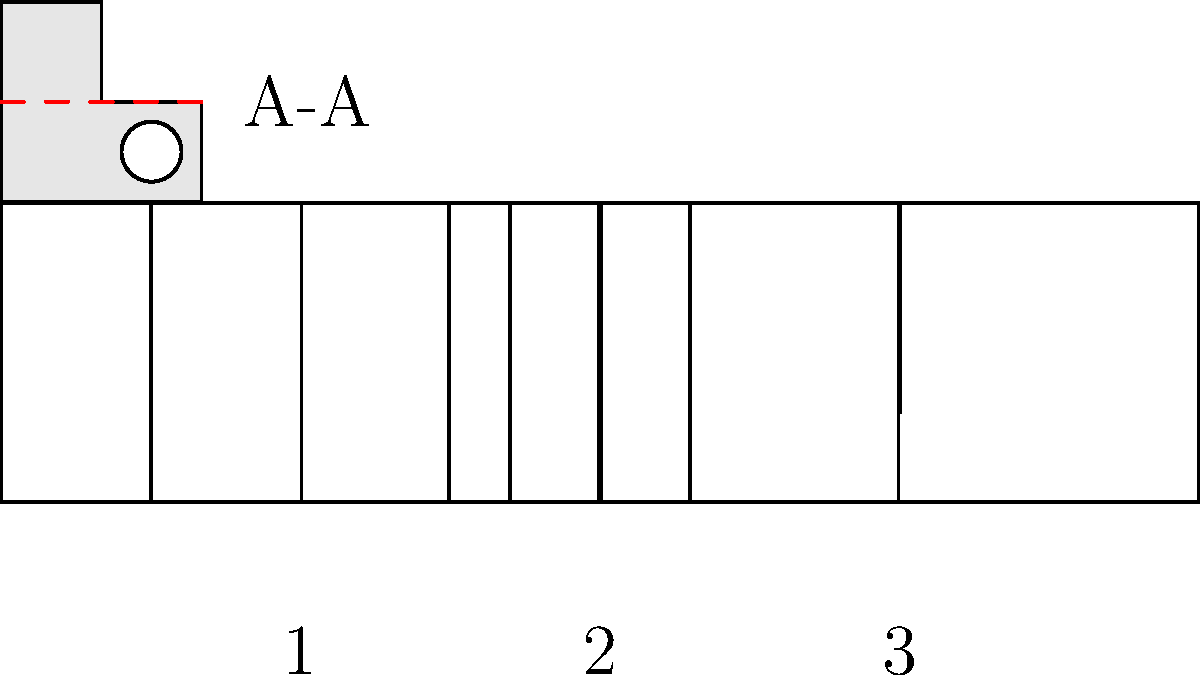The image shows a top view of an intricate mechanical part with a cross-section line A-A. Which of the numbered views (1, 2, or 3) correctly represents the cross-section along line A-A? To determine the correct cross-section view, let's analyze the part and the given options step-by-step:

1. Observe the top view of the part:
   - It has a rectangular outer shape.
   - There's a circular cutout on the right side.
   - The cross-section line A-A passes through the middle of the part.

2. Analyze what the cross-section A-A would look like:
   - It should show the full width of the part.
   - The left side would be solid.
   - The right side would have a gap where the circular cutout intersects the cross-section line.

3. Examine the given options:
   - View 1: Shows two vertical lines, which doesn't match our expected cross-section.
   - View 2: Shows two vertical lines closer together, which also doesn't match.
   - View 3: Shows a single vertical line on the right side, which matches our expectation of the circular cutout.

4. Compare the analysis with engineering knowledge:
   - In mechanical engineering, cross-sections typically show solid areas as filled or hatched.
   - The gap created by the circular cutout would appear as an empty space in the cross-section.

5. Conclusion:
   View 3 correctly represents the cross-section along line A-A. It shows the full width of the part with a solid left side and a gap on the right side where the circular cutout intersects the cross-section line.
Answer: 3 